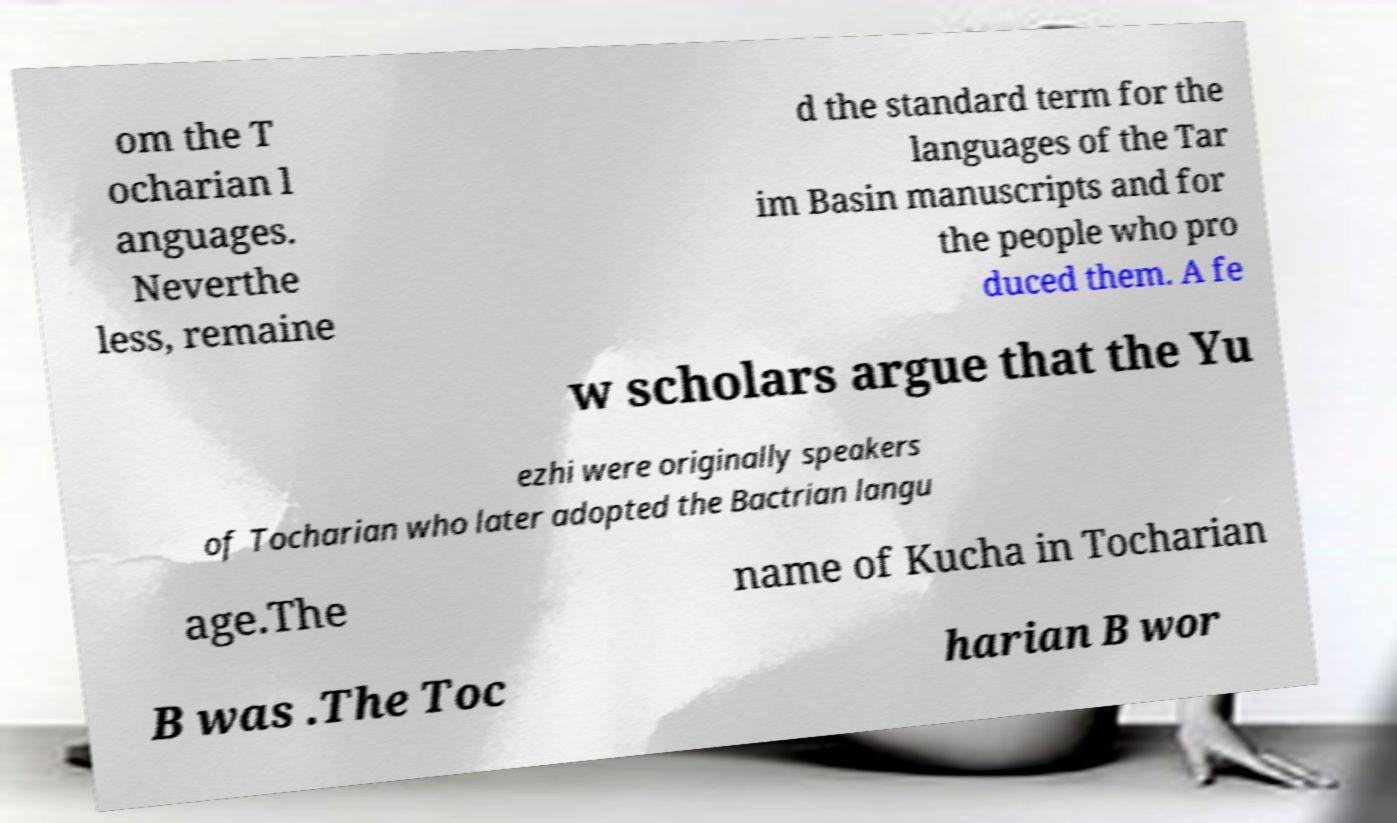What messages or text are displayed in this image? I need them in a readable, typed format. om the T ocharian l anguages. Neverthe less, remaine d the standard term for the languages of the Tar im Basin manuscripts and for the people who pro duced them. A fe w scholars argue that the Yu ezhi were originally speakers of Tocharian who later adopted the Bactrian langu age.The name of Kucha in Tocharian B was .The Toc harian B wor 